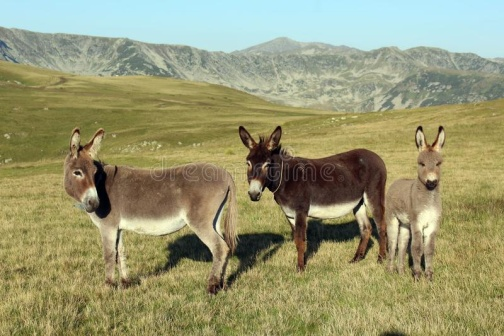Imagine if the donkeys in the image could speak. What might they be discussing? Gray Donkey on the Left: 'You know, this field has the best grazing spots. The grass is not just abundant but exceptionally flavorful.'
Brown Donkey in the Middle: 'I agree, and the view is rather majestic. I feel a sense of peace here, don't you think?'
Gray Donkey on the Right: 'Absolutely, especially with those mountains watching over us. It's like nature's own fortress.' 